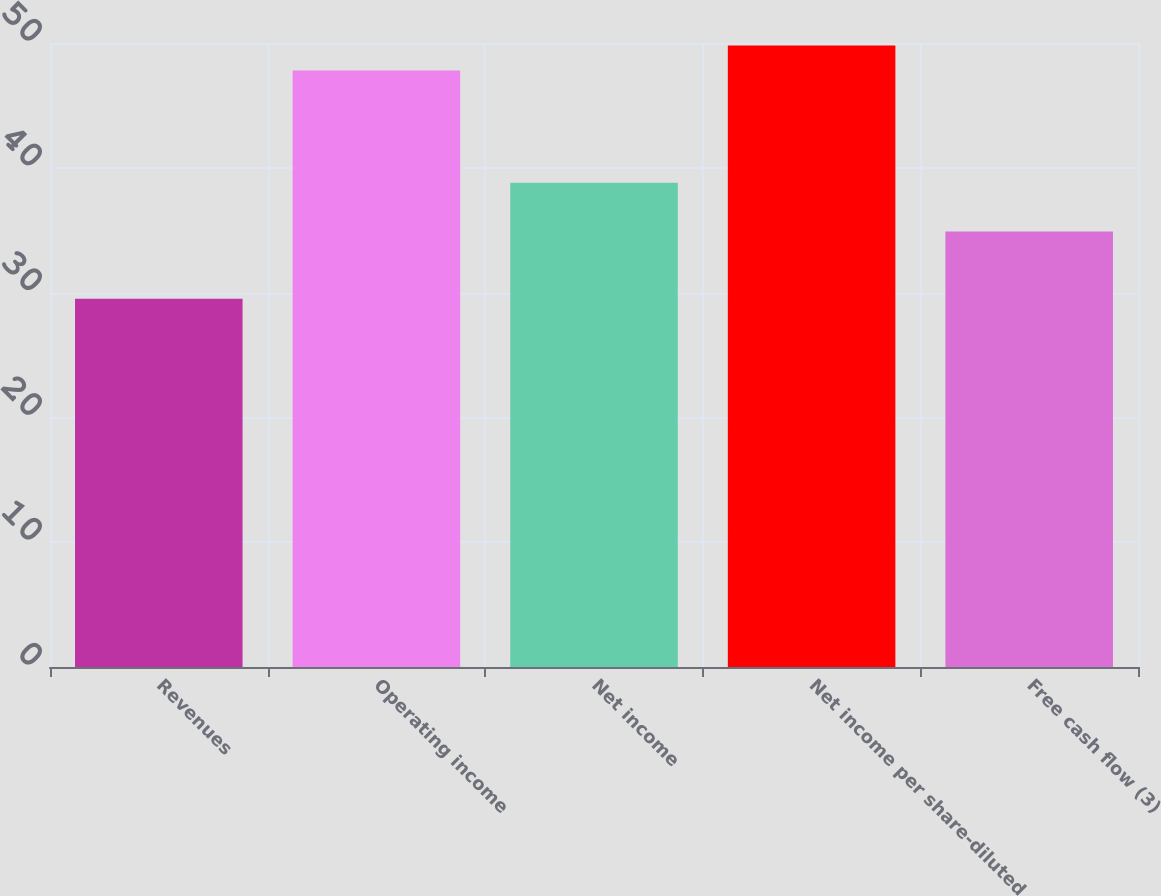<chart> <loc_0><loc_0><loc_500><loc_500><bar_chart><fcel>Revenues<fcel>Operating income<fcel>Net income<fcel>Net income per share-diluted<fcel>Free cash flow (3)<nl><fcel>29.5<fcel>47.8<fcel>38.8<fcel>49.8<fcel>34.9<nl></chart> 